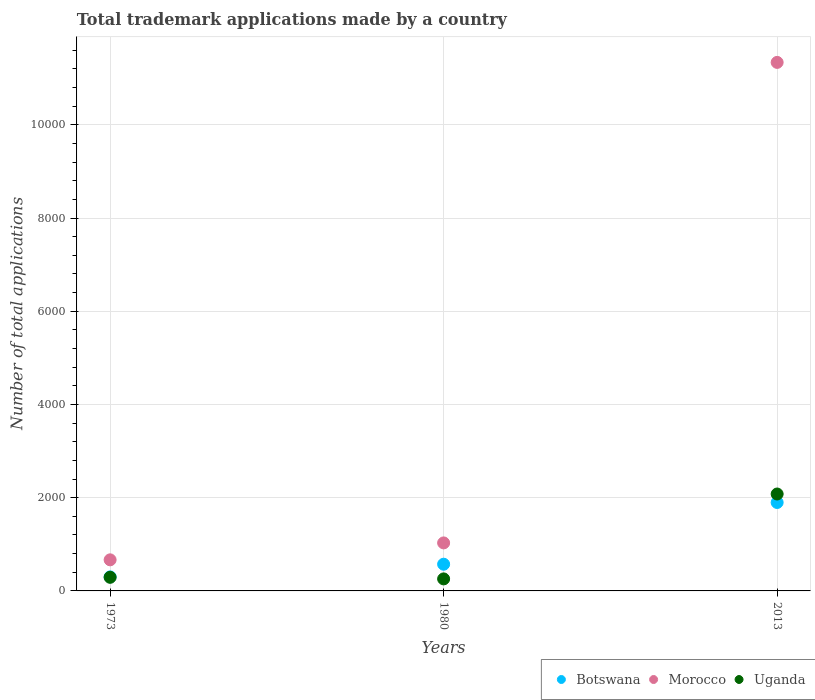Is the number of dotlines equal to the number of legend labels?
Offer a very short reply. Yes. What is the number of applications made by in Morocco in 2013?
Keep it short and to the point. 1.13e+04. Across all years, what is the maximum number of applications made by in Botswana?
Make the answer very short. 1897. Across all years, what is the minimum number of applications made by in Uganda?
Ensure brevity in your answer.  258. In which year was the number of applications made by in Uganda minimum?
Your response must be concise. 1980. What is the total number of applications made by in Botswana in the graph?
Keep it short and to the point. 2771. What is the difference between the number of applications made by in Botswana in 1973 and that in 2013?
Provide a succinct answer. -1596. What is the difference between the number of applications made by in Uganda in 1973 and the number of applications made by in Botswana in 1980?
Offer a terse response. -281. What is the average number of applications made by in Botswana per year?
Keep it short and to the point. 923.67. In the year 1973, what is the difference between the number of applications made by in Botswana and number of applications made by in Morocco?
Your answer should be very brief. -366. What is the ratio of the number of applications made by in Botswana in 1973 to that in 1980?
Ensure brevity in your answer.  0.53. Is the difference between the number of applications made by in Botswana in 1973 and 1980 greater than the difference between the number of applications made by in Morocco in 1973 and 1980?
Provide a short and direct response. Yes. What is the difference between the highest and the second highest number of applications made by in Botswana?
Provide a short and direct response. 1324. What is the difference between the highest and the lowest number of applications made by in Uganda?
Keep it short and to the point. 1821. Is the sum of the number of applications made by in Botswana in 1973 and 1980 greater than the maximum number of applications made by in Morocco across all years?
Give a very brief answer. No. Is it the case that in every year, the sum of the number of applications made by in Uganda and number of applications made by in Botswana  is greater than the number of applications made by in Morocco?
Ensure brevity in your answer.  No. Does the number of applications made by in Botswana monotonically increase over the years?
Provide a succinct answer. Yes. Is the number of applications made by in Botswana strictly greater than the number of applications made by in Morocco over the years?
Your answer should be compact. No. How many years are there in the graph?
Your response must be concise. 3. Does the graph contain any zero values?
Ensure brevity in your answer.  No. Does the graph contain grids?
Provide a short and direct response. Yes. How many legend labels are there?
Ensure brevity in your answer.  3. What is the title of the graph?
Offer a very short reply. Total trademark applications made by a country. Does "Czech Republic" appear as one of the legend labels in the graph?
Make the answer very short. No. What is the label or title of the X-axis?
Make the answer very short. Years. What is the label or title of the Y-axis?
Offer a terse response. Number of total applications. What is the Number of total applications of Botswana in 1973?
Provide a short and direct response. 301. What is the Number of total applications of Morocco in 1973?
Your response must be concise. 667. What is the Number of total applications in Uganda in 1973?
Offer a very short reply. 292. What is the Number of total applications in Botswana in 1980?
Ensure brevity in your answer.  573. What is the Number of total applications of Morocco in 1980?
Offer a very short reply. 1030. What is the Number of total applications of Uganda in 1980?
Offer a terse response. 258. What is the Number of total applications of Botswana in 2013?
Your answer should be compact. 1897. What is the Number of total applications in Morocco in 2013?
Your response must be concise. 1.13e+04. What is the Number of total applications of Uganda in 2013?
Make the answer very short. 2079. Across all years, what is the maximum Number of total applications of Botswana?
Keep it short and to the point. 1897. Across all years, what is the maximum Number of total applications of Morocco?
Your response must be concise. 1.13e+04. Across all years, what is the maximum Number of total applications of Uganda?
Your answer should be very brief. 2079. Across all years, what is the minimum Number of total applications of Botswana?
Provide a succinct answer. 301. Across all years, what is the minimum Number of total applications in Morocco?
Your response must be concise. 667. Across all years, what is the minimum Number of total applications of Uganda?
Offer a terse response. 258. What is the total Number of total applications of Botswana in the graph?
Keep it short and to the point. 2771. What is the total Number of total applications of Morocco in the graph?
Provide a short and direct response. 1.30e+04. What is the total Number of total applications of Uganda in the graph?
Offer a very short reply. 2629. What is the difference between the Number of total applications of Botswana in 1973 and that in 1980?
Provide a short and direct response. -272. What is the difference between the Number of total applications in Morocco in 1973 and that in 1980?
Your response must be concise. -363. What is the difference between the Number of total applications in Uganda in 1973 and that in 1980?
Your answer should be compact. 34. What is the difference between the Number of total applications of Botswana in 1973 and that in 2013?
Your answer should be compact. -1596. What is the difference between the Number of total applications of Morocco in 1973 and that in 2013?
Provide a short and direct response. -1.07e+04. What is the difference between the Number of total applications in Uganda in 1973 and that in 2013?
Your answer should be compact. -1787. What is the difference between the Number of total applications in Botswana in 1980 and that in 2013?
Offer a terse response. -1324. What is the difference between the Number of total applications of Morocco in 1980 and that in 2013?
Make the answer very short. -1.03e+04. What is the difference between the Number of total applications in Uganda in 1980 and that in 2013?
Your response must be concise. -1821. What is the difference between the Number of total applications in Botswana in 1973 and the Number of total applications in Morocco in 1980?
Offer a very short reply. -729. What is the difference between the Number of total applications of Botswana in 1973 and the Number of total applications of Uganda in 1980?
Your response must be concise. 43. What is the difference between the Number of total applications in Morocco in 1973 and the Number of total applications in Uganda in 1980?
Keep it short and to the point. 409. What is the difference between the Number of total applications in Botswana in 1973 and the Number of total applications in Morocco in 2013?
Your answer should be very brief. -1.10e+04. What is the difference between the Number of total applications of Botswana in 1973 and the Number of total applications of Uganda in 2013?
Keep it short and to the point. -1778. What is the difference between the Number of total applications in Morocco in 1973 and the Number of total applications in Uganda in 2013?
Provide a short and direct response. -1412. What is the difference between the Number of total applications in Botswana in 1980 and the Number of total applications in Morocco in 2013?
Give a very brief answer. -1.08e+04. What is the difference between the Number of total applications in Botswana in 1980 and the Number of total applications in Uganda in 2013?
Provide a succinct answer. -1506. What is the difference between the Number of total applications of Morocco in 1980 and the Number of total applications of Uganda in 2013?
Your answer should be compact. -1049. What is the average Number of total applications in Botswana per year?
Your answer should be compact. 923.67. What is the average Number of total applications in Morocco per year?
Make the answer very short. 4345. What is the average Number of total applications of Uganda per year?
Ensure brevity in your answer.  876.33. In the year 1973, what is the difference between the Number of total applications in Botswana and Number of total applications in Morocco?
Provide a succinct answer. -366. In the year 1973, what is the difference between the Number of total applications of Morocco and Number of total applications of Uganda?
Provide a short and direct response. 375. In the year 1980, what is the difference between the Number of total applications of Botswana and Number of total applications of Morocco?
Ensure brevity in your answer.  -457. In the year 1980, what is the difference between the Number of total applications in Botswana and Number of total applications in Uganda?
Make the answer very short. 315. In the year 1980, what is the difference between the Number of total applications in Morocco and Number of total applications in Uganda?
Ensure brevity in your answer.  772. In the year 2013, what is the difference between the Number of total applications in Botswana and Number of total applications in Morocco?
Offer a very short reply. -9441. In the year 2013, what is the difference between the Number of total applications of Botswana and Number of total applications of Uganda?
Offer a terse response. -182. In the year 2013, what is the difference between the Number of total applications in Morocco and Number of total applications in Uganda?
Provide a short and direct response. 9259. What is the ratio of the Number of total applications in Botswana in 1973 to that in 1980?
Offer a very short reply. 0.53. What is the ratio of the Number of total applications of Morocco in 1973 to that in 1980?
Ensure brevity in your answer.  0.65. What is the ratio of the Number of total applications in Uganda in 1973 to that in 1980?
Your response must be concise. 1.13. What is the ratio of the Number of total applications of Botswana in 1973 to that in 2013?
Keep it short and to the point. 0.16. What is the ratio of the Number of total applications of Morocco in 1973 to that in 2013?
Give a very brief answer. 0.06. What is the ratio of the Number of total applications in Uganda in 1973 to that in 2013?
Provide a short and direct response. 0.14. What is the ratio of the Number of total applications in Botswana in 1980 to that in 2013?
Ensure brevity in your answer.  0.3. What is the ratio of the Number of total applications in Morocco in 1980 to that in 2013?
Your response must be concise. 0.09. What is the ratio of the Number of total applications of Uganda in 1980 to that in 2013?
Offer a very short reply. 0.12. What is the difference between the highest and the second highest Number of total applications in Botswana?
Provide a succinct answer. 1324. What is the difference between the highest and the second highest Number of total applications of Morocco?
Your response must be concise. 1.03e+04. What is the difference between the highest and the second highest Number of total applications in Uganda?
Make the answer very short. 1787. What is the difference between the highest and the lowest Number of total applications of Botswana?
Ensure brevity in your answer.  1596. What is the difference between the highest and the lowest Number of total applications in Morocco?
Keep it short and to the point. 1.07e+04. What is the difference between the highest and the lowest Number of total applications of Uganda?
Provide a succinct answer. 1821. 